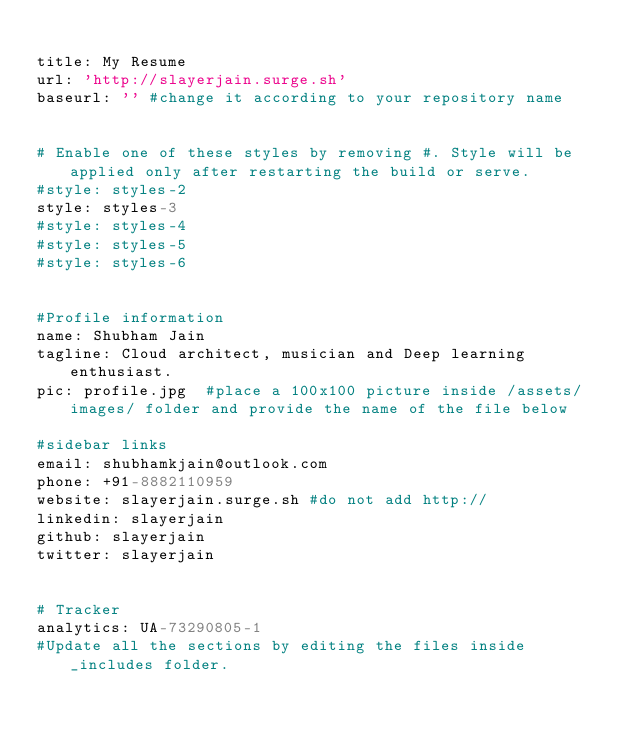Convert code to text. <code><loc_0><loc_0><loc_500><loc_500><_YAML_>
title: My Resume
url: 'http://slayerjain.surge.sh'
baseurl: '' #change it according to your repository name


# Enable one of these styles by removing #. Style will be applied only after restarting the build or serve.
#style: styles-2
style: styles-3
#style: styles-4
#style: styles-5
#style: styles-6


#Profile information
name: Shubham Jain
tagline: Cloud architect, musician and Deep learning enthusiast. 
pic: profile.jpg  #place a 100x100 picture inside /assets/images/ folder and provide the name of the file below

#sidebar links
email: shubhamkjain@outlook.com
phone: +91-8882110959
website: slayerjain.surge.sh #do not add http://
linkedin: slayerjain
github: slayerjain
twitter: slayerjain


# Tracker
analytics: UA-73290805-1
#Update all the sections by editing the files inside _includes folder.
</code> 